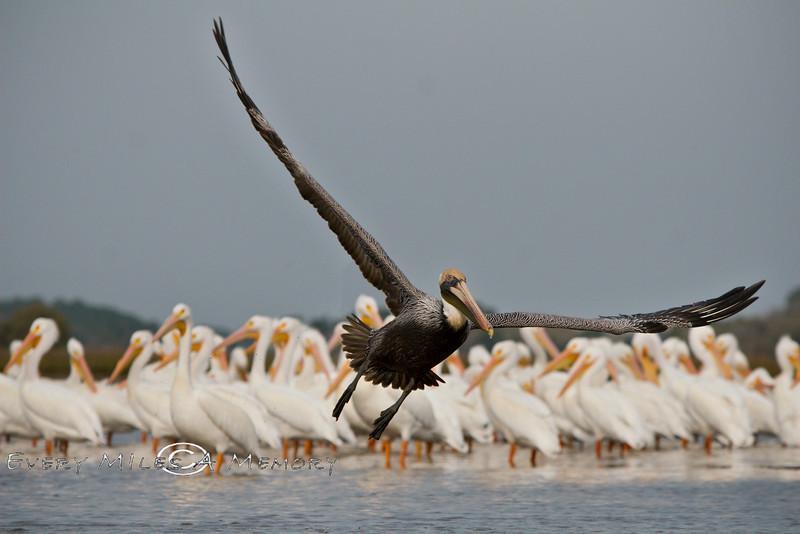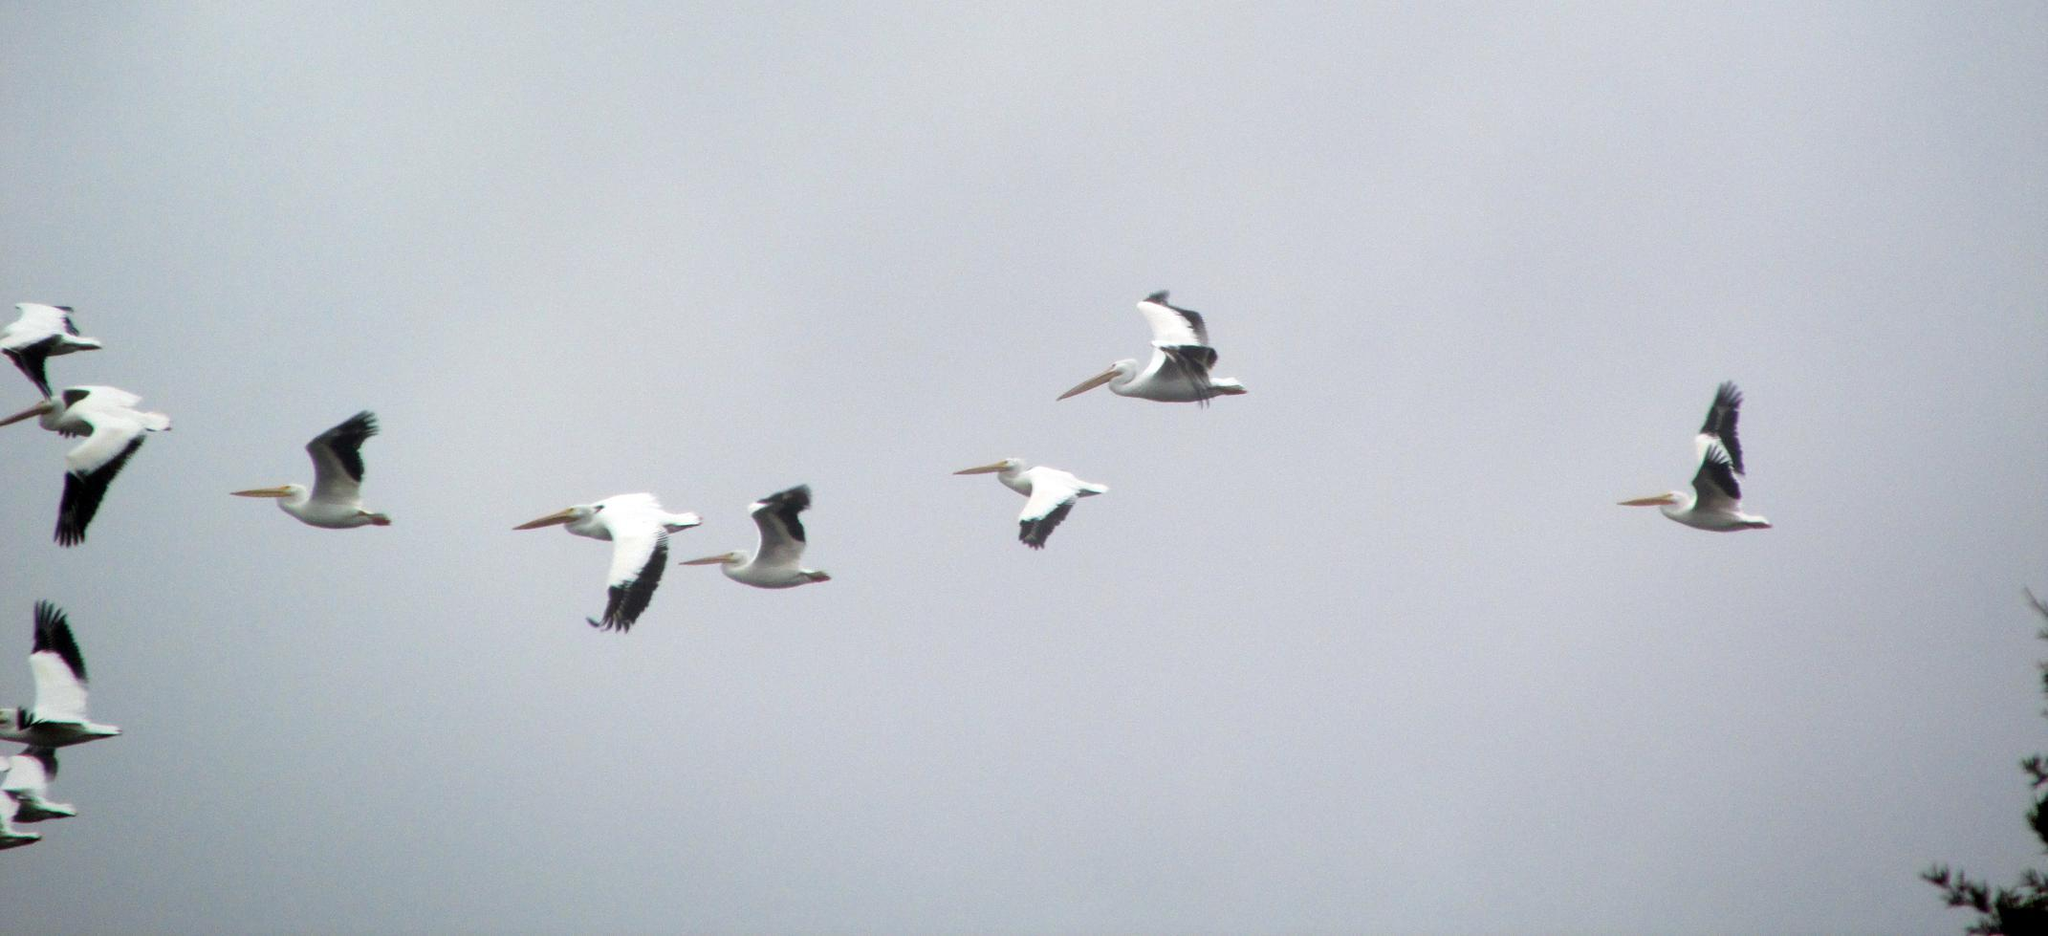The first image is the image on the left, the second image is the image on the right. Analyze the images presented: Is the assertion "A single bird is flying in the image on the left." valid? Answer yes or no. Yes. The first image is the image on the left, the second image is the image on the right. Examine the images to the left and right. Is the description "A single dark pelican flying with outspread wings is in the foreground of the left image, and the right image shows at least 10 pelicans flying leftward." accurate? Answer yes or no. Yes. 